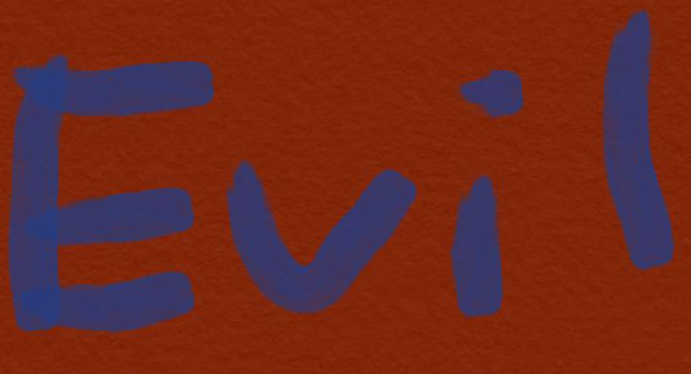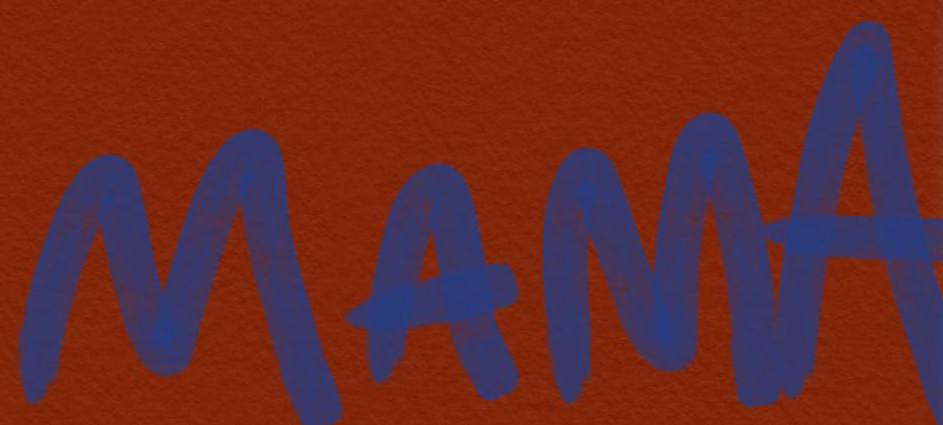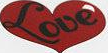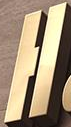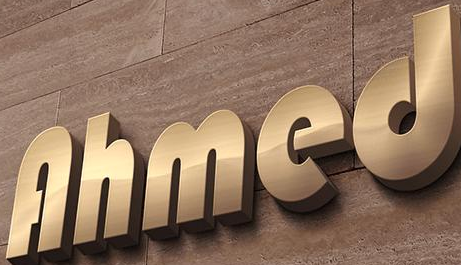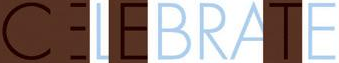Read the text from these images in sequence, separated by a semicolon. Evil; MAMA; Love; H; Ahmed; CELEBRATE 